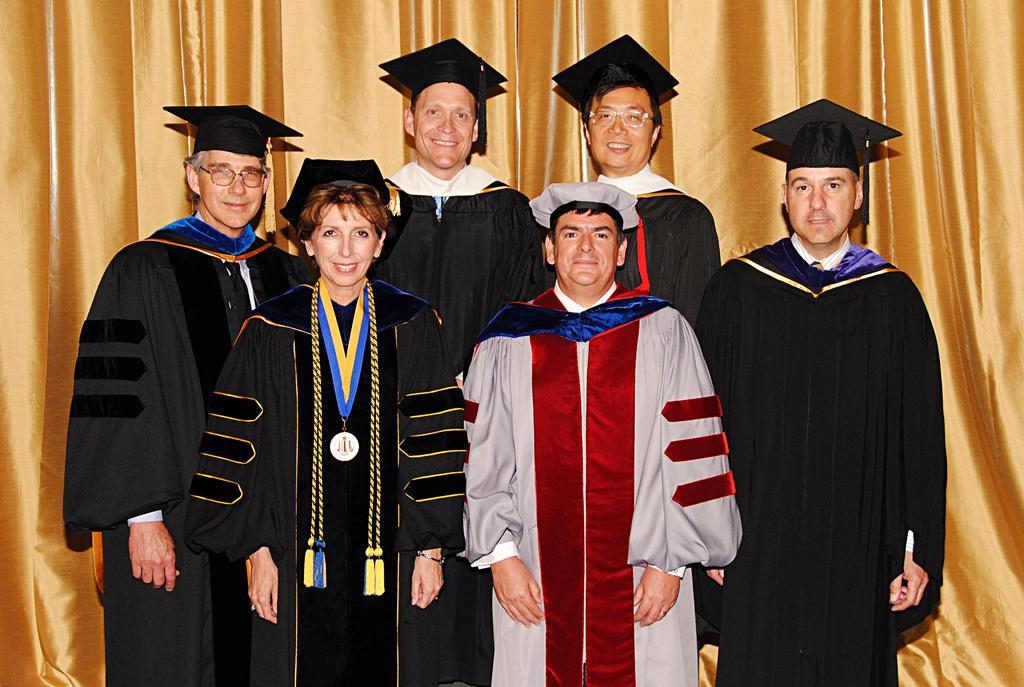Please provide a concise description of this image. In this image we can see a group of people wearing dress and caps. One woman is wearing a, medal in her neck. One person is wearing spectacles. In the background, we can see the curtains. 